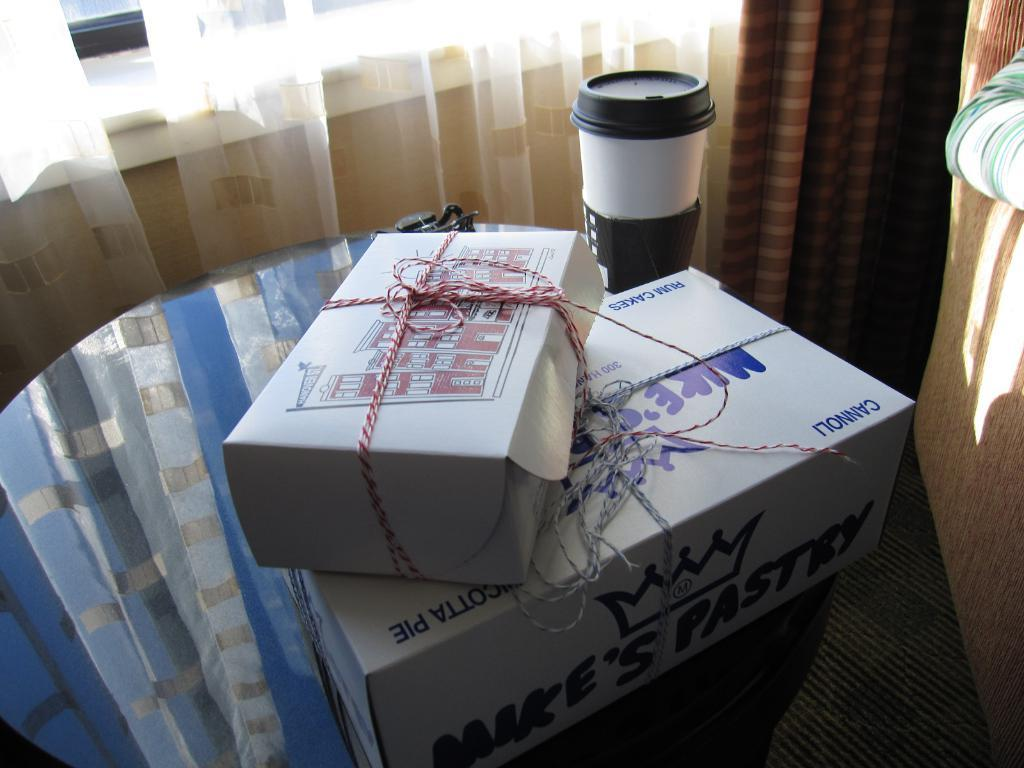<image>
Provide a brief description of the given image. two boxes from Mike's Pastry on a table 